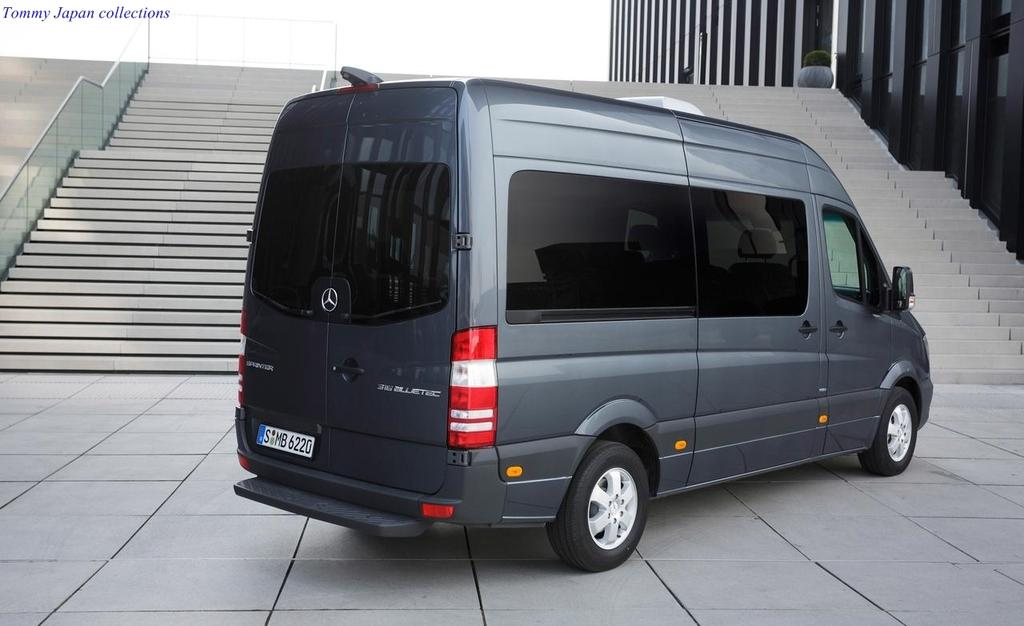Provide a one-sentence caption for the provided image. A cobalt-colored transport van with dark glass was built by the Mercedes-Benz company. 